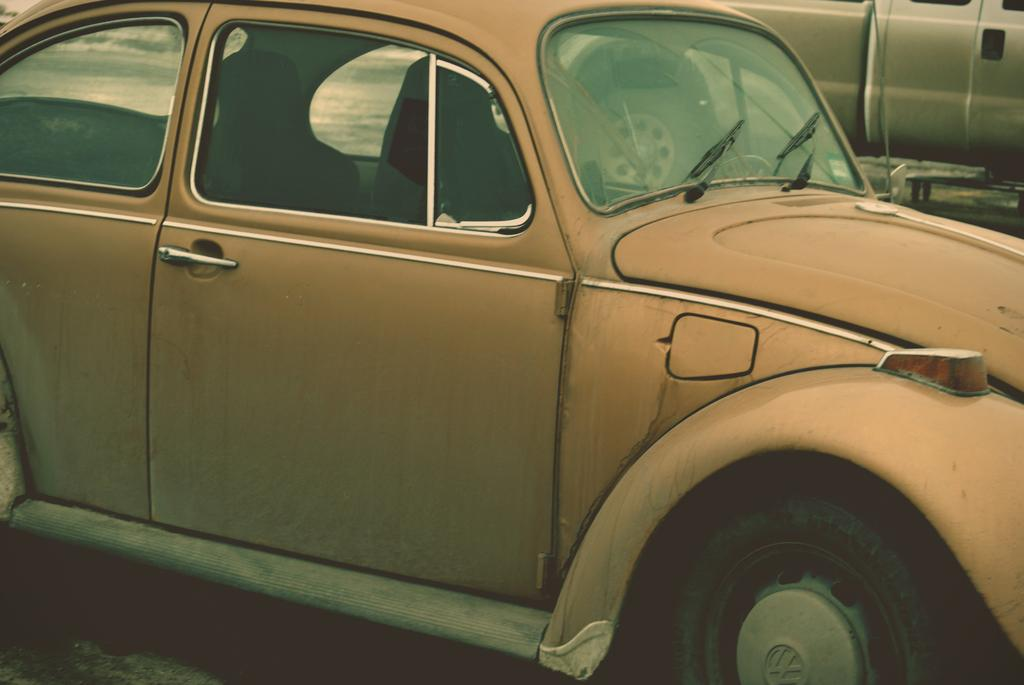How many vehicles are present in the image? There are two vehicles in the image. What type of can is visible in the image? There is no can present in the image; it only features two vehicles. How many feet are visible in the image? There is no reference to feet or any human or animal presence in the image, so it is not possible to determine the number of feet visible. 